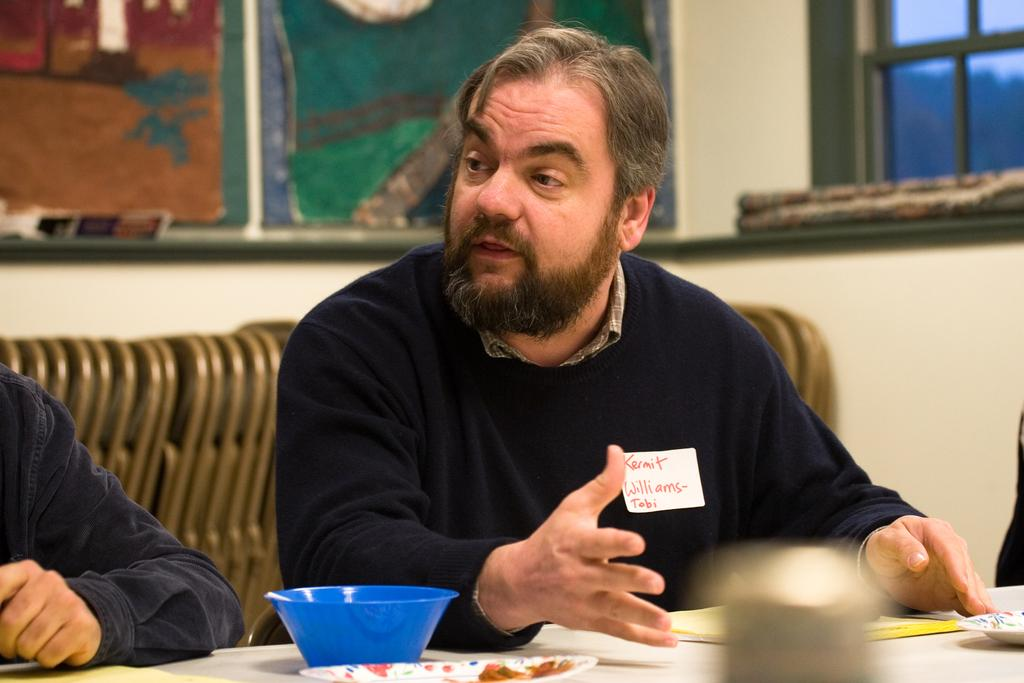What is the man in the image doing? The man is sitting on a chair in the image. What objects are present on the table in the image? There is a bowl and a plate in the image. What is the other person in the image holding? There is a book in the image. How many people are present in the image? There are two people in the image. What type of mist can be seen surrounding the man in the image? There is no mist present in the image; it is a clear scene. 